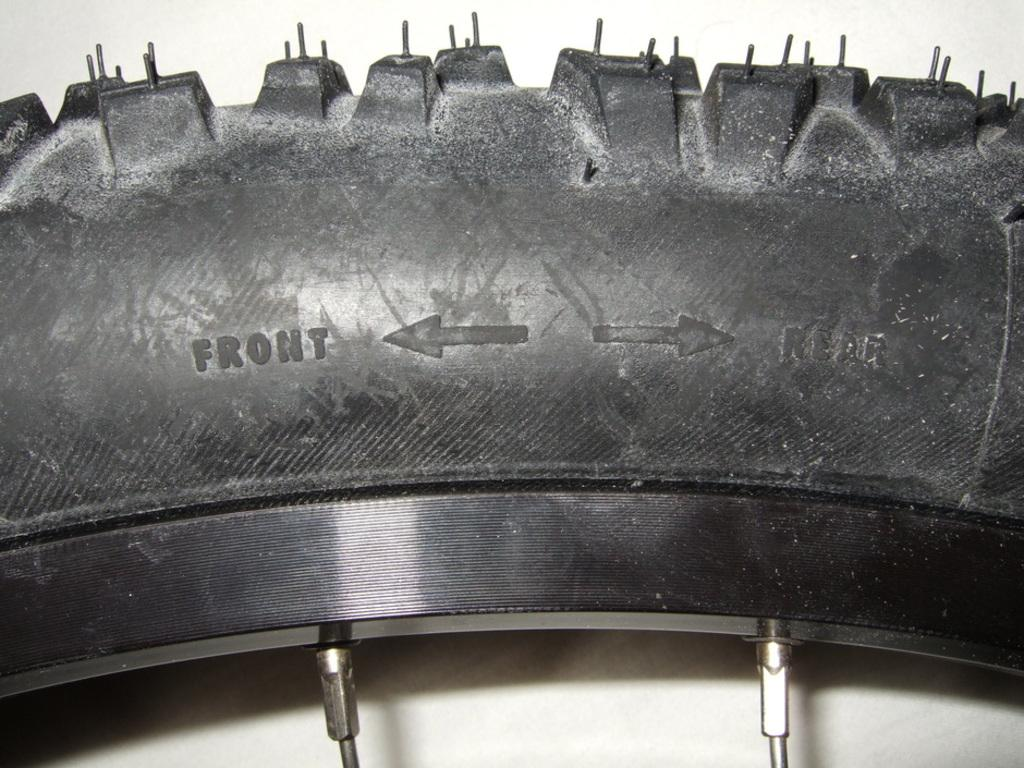What object is the main focus of the image? There is a tire in the image. What is written on the tire? There is writing on the tire. What directional symbols are present in the image? There are arrows in the image. What color are the objects in the image? There are silver-colored objects in the image. What is the color of the background in the image? The background of the image is white. Can you see a crowd of people gathered around the tire in the image? No, there is no crowd of people present in the image. What type of pipe is connected to the tire in the image? There is no pipe connected to the tire in the image. 